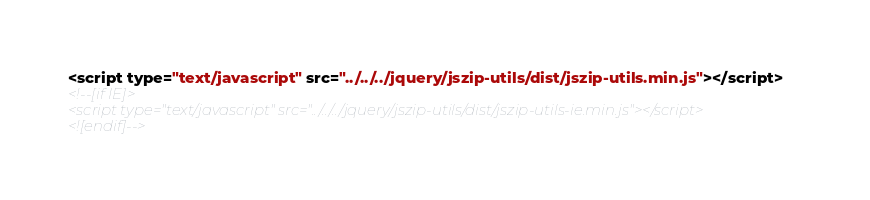<code> <loc_0><loc_0><loc_500><loc_500><_HTML_><script type="text/javascript" src="../../../jquery/jszip-utils/dist/jszip-utils.min.js"></script>
<!--[if IE]>
<script type="text/javascript" src="../../../jquery/jszip-utils/dist/jszip-utils-ie.min.js"></script>
<![endif]--></code> 